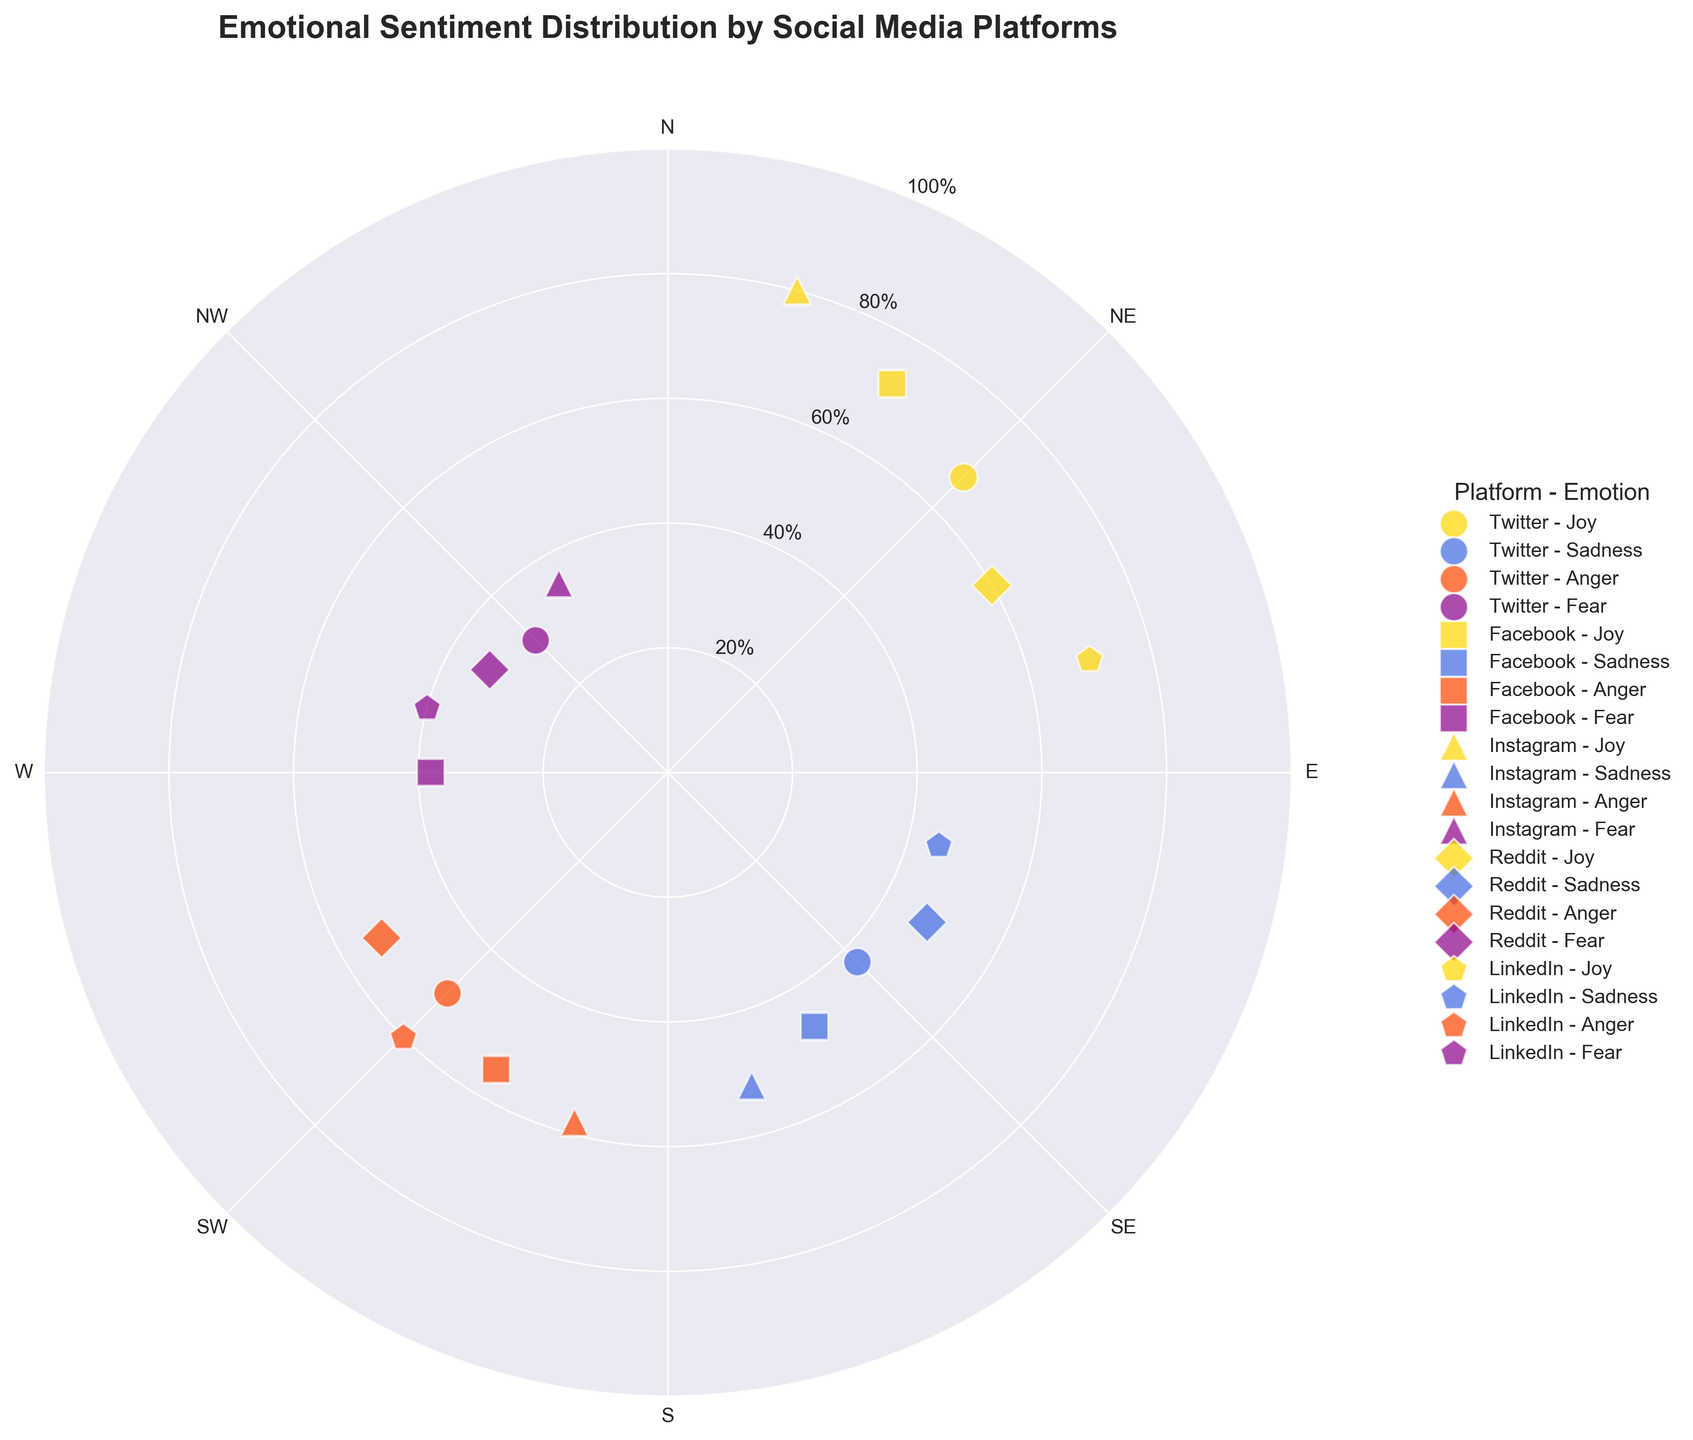What's the title of the figure? The title of the figure is displayed prominently at the top of the chart.
Answer: Emotional Sentiment Distribution by Social Media Platforms Which platform shows the highest radius for Joy? By looking for the 'Joy' emotion markers and comparing their radial distances from the center, the marker with the highest radius belongs to Instagram.
Answer: Instagram What is the radius value for LinkedIn's Anger? Locate the LinkedIn markers and identify the Anger marker, then read its radial distance from the center.
Answer: 60 How does the radius for Facebook's Fear compare to Twitter's Fear? Compare the radial distances of the Fear markers for both Facebook and Twitter; Facebook's Fear has a greater radius.
Answer: Facebook's Fear is greater For which emotion do all social media platforms have a similar range of radius values? Check the distribution and range of radii for each emotion across platforms; most consistent ranges are observed for Fear.
Answer: Fear What are the four emotions represented in the chart? Check the labels and colors representing different emotions used in the chart.
Answer: Joy, Sadness, Anger, Fear Which platform has the lowest radius for Joy? Compare the radial distances for the Joy markers for all platforms; Reddit has the lowest radius for Joy.
Answer: Reddit On which angle is Facebook's Joy sentiment located? Identify the Joy marker for Facebook and note its angular position, which corresponds to 30 degrees.
Answer: 30 degrees What is the overall trend for Anger emotion across the platforms in terms of radius? Examine the radial distances of the Anger markers for all platforms; most platforms show a moderate to high radius for Anger.
Answer: Moderate to high How many data points are there in total on the Polar Scatter Chart? Count the total number of markers, each representing a data point for different emotions across platforms.
Answer: 20 